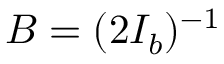Convert formula to latex. <formula><loc_0><loc_0><loc_500><loc_500>B = ( 2 I _ { b } ) ^ { - 1 }</formula> 